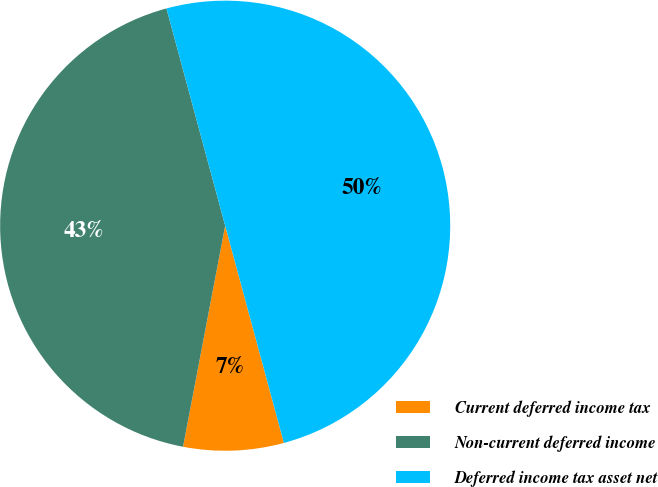Convert chart to OTSL. <chart><loc_0><loc_0><loc_500><loc_500><pie_chart><fcel>Current deferred income tax<fcel>Non-current deferred income<fcel>Deferred income tax asset net<nl><fcel>7.2%<fcel>42.8%<fcel>50.0%<nl></chart> 